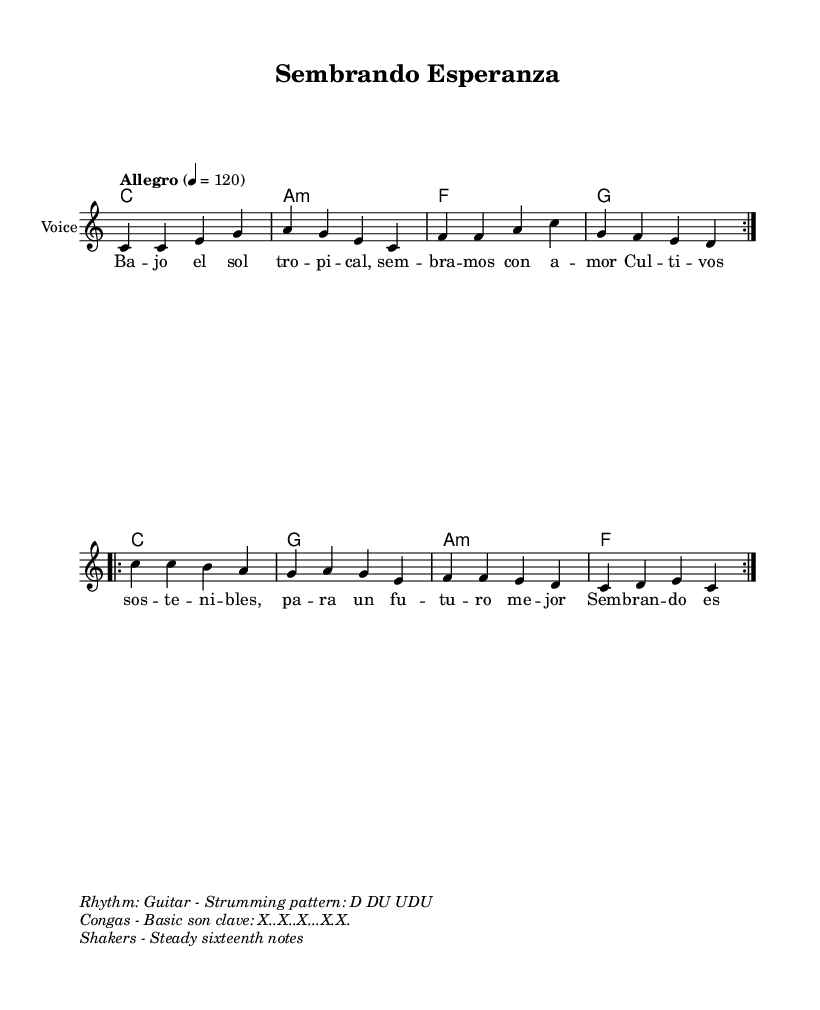What is the tempo marking of this music? The tempo marking, found at the beginning of the score, indicates the speed of the piece. It says "Allegro" with a tempo of 120 beats per minute.
Answer: Allegro What is the time signature of this music? The time signature at the beginning of the score specifies how many beats are in each measure. It shows 4/4, indicating four beats per measure.
Answer: 4/4 What is the key signature of this music? The key signature is indicated at the beginning of the score. It shows there are no sharps or flats, which corresponds to C major.
Answer: C major How many times is the first section repeated? The repeat markings in the score denote that the first section is to be played twice, as indicated by "repeat volta 2."
Answer: 2 What rhythmic pattern is indicated for the guitar? The rhythmic pattern for the guitar strumming is specified in the markup section. It indicates a pattern of down and up strokes.
Answer: D DU UDU What is the main theme of the lyrics? The lyrics contain themes about sustainable agriculture and hope for a better future, focusing on the importance of eco-friendly practices.
Answer: Sustainable agriculture 